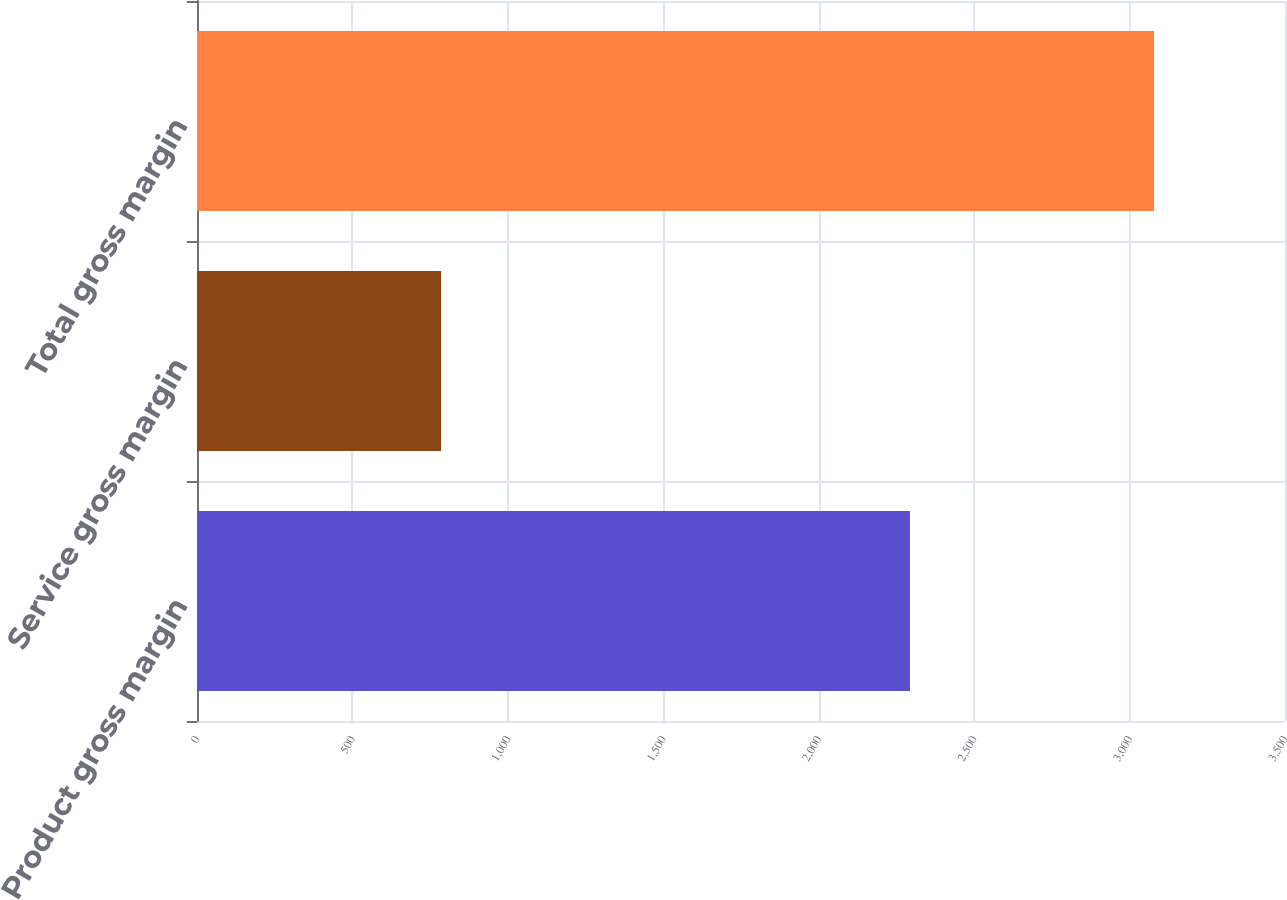Convert chart. <chart><loc_0><loc_0><loc_500><loc_500><bar_chart><fcel>Product gross margin<fcel>Service gross margin<fcel>Total gross margin<nl><fcel>2293.5<fcel>785.1<fcel>3078.6<nl></chart> 